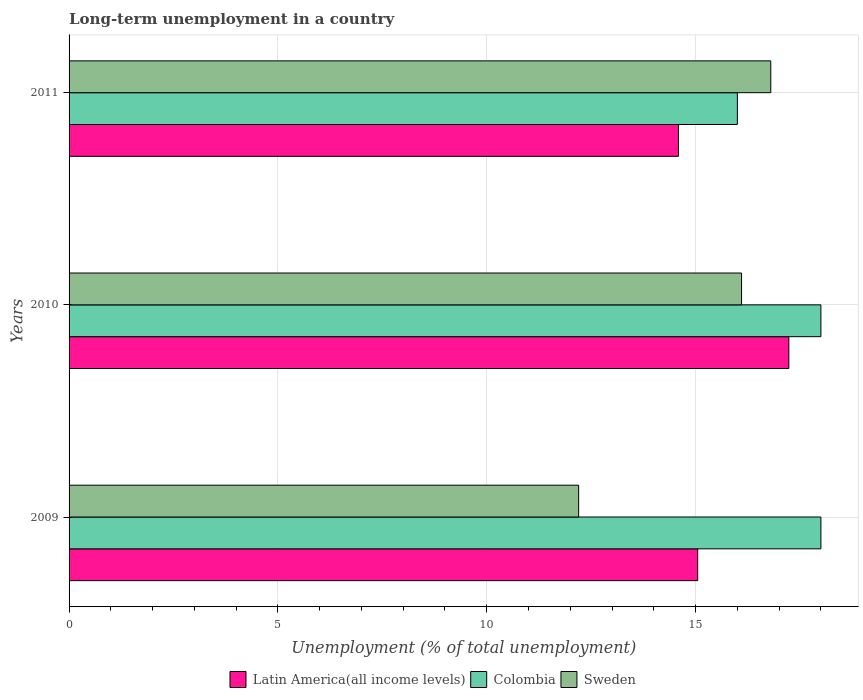Are the number of bars per tick equal to the number of legend labels?
Your answer should be compact. Yes. How many bars are there on the 1st tick from the top?
Ensure brevity in your answer.  3. How many bars are there on the 2nd tick from the bottom?
Provide a succinct answer. 3. What is the label of the 2nd group of bars from the top?
Ensure brevity in your answer.  2010. In how many cases, is the number of bars for a given year not equal to the number of legend labels?
Keep it short and to the point. 0. What is the percentage of long-term unemployed population in Sweden in 2011?
Provide a succinct answer. 16.8. Across all years, what is the maximum percentage of long-term unemployed population in Sweden?
Your answer should be compact. 16.8. Across all years, what is the minimum percentage of long-term unemployed population in Latin America(all income levels)?
Ensure brevity in your answer.  14.59. In which year was the percentage of long-term unemployed population in Colombia minimum?
Keep it short and to the point. 2011. What is the total percentage of long-term unemployed population in Colombia in the graph?
Provide a succinct answer. 52. What is the difference between the percentage of long-term unemployed population in Sweden in 2010 and the percentage of long-term unemployed population in Colombia in 2009?
Your answer should be very brief. -1.9. What is the average percentage of long-term unemployed population in Sweden per year?
Provide a short and direct response. 15.03. In the year 2009, what is the difference between the percentage of long-term unemployed population in Colombia and percentage of long-term unemployed population in Latin America(all income levels)?
Your response must be concise. 2.95. In how many years, is the percentage of long-term unemployed population in Colombia greater than 12 %?
Offer a very short reply. 3. What is the ratio of the percentage of long-term unemployed population in Latin America(all income levels) in 2010 to that in 2011?
Provide a succinct answer. 1.18. Is the percentage of long-term unemployed population in Colombia in 2010 less than that in 2011?
Offer a very short reply. No. Is the difference between the percentage of long-term unemployed population in Colombia in 2010 and 2011 greater than the difference between the percentage of long-term unemployed population in Latin America(all income levels) in 2010 and 2011?
Your answer should be very brief. No. What is the difference between the highest and the second highest percentage of long-term unemployed population in Colombia?
Your answer should be very brief. 0. What is the difference between the highest and the lowest percentage of long-term unemployed population in Sweden?
Your answer should be compact. 4.6. In how many years, is the percentage of long-term unemployed population in Colombia greater than the average percentage of long-term unemployed population in Colombia taken over all years?
Make the answer very short. 2. What does the 3rd bar from the top in 2010 represents?
Provide a succinct answer. Latin America(all income levels). Is it the case that in every year, the sum of the percentage of long-term unemployed population in Colombia and percentage of long-term unemployed population in Sweden is greater than the percentage of long-term unemployed population in Latin America(all income levels)?
Make the answer very short. Yes. How many bars are there?
Provide a succinct answer. 9. Are all the bars in the graph horizontal?
Your answer should be compact. Yes. How many years are there in the graph?
Offer a terse response. 3. What is the difference between two consecutive major ticks on the X-axis?
Give a very brief answer. 5. Are the values on the major ticks of X-axis written in scientific E-notation?
Ensure brevity in your answer.  No. Does the graph contain any zero values?
Keep it short and to the point. No. Does the graph contain grids?
Give a very brief answer. Yes. Where does the legend appear in the graph?
Give a very brief answer. Bottom center. What is the title of the graph?
Your answer should be compact. Long-term unemployment in a country. What is the label or title of the X-axis?
Ensure brevity in your answer.  Unemployment (% of total unemployment). What is the Unemployment (% of total unemployment) in Latin America(all income levels) in 2009?
Offer a terse response. 15.05. What is the Unemployment (% of total unemployment) in Sweden in 2009?
Your response must be concise. 12.2. What is the Unemployment (% of total unemployment) of Latin America(all income levels) in 2010?
Make the answer very short. 17.23. What is the Unemployment (% of total unemployment) in Sweden in 2010?
Your response must be concise. 16.1. What is the Unemployment (% of total unemployment) in Latin America(all income levels) in 2011?
Your response must be concise. 14.59. What is the Unemployment (% of total unemployment) of Sweden in 2011?
Your answer should be very brief. 16.8. Across all years, what is the maximum Unemployment (% of total unemployment) in Latin America(all income levels)?
Your answer should be compact. 17.23. Across all years, what is the maximum Unemployment (% of total unemployment) of Sweden?
Your answer should be compact. 16.8. Across all years, what is the minimum Unemployment (% of total unemployment) of Latin America(all income levels)?
Offer a terse response. 14.59. Across all years, what is the minimum Unemployment (% of total unemployment) of Colombia?
Give a very brief answer. 16. Across all years, what is the minimum Unemployment (% of total unemployment) in Sweden?
Ensure brevity in your answer.  12.2. What is the total Unemployment (% of total unemployment) of Latin America(all income levels) in the graph?
Give a very brief answer. 46.87. What is the total Unemployment (% of total unemployment) in Colombia in the graph?
Provide a short and direct response. 52. What is the total Unemployment (% of total unemployment) in Sweden in the graph?
Provide a succinct answer. 45.1. What is the difference between the Unemployment (% of total unemployment) in Latin America(all income levels) in 2009 and that in 2010?
Ensure brevity in your answer.  -2.18. What is the difference between the Unemployment (% of total unemployment) of Colombia in 2009 and that in 2010?
Offer a terse response. 0. What is the difference between the Unemployment (% of total unemployment) in Latin America(all income levels) in 2009 and that in 2011?
Your response must be concise. 0.46. What is the difference between the Unemployment (% of total unemployment) of Colombia in 2009 and that in 2011?
Your response must be concise. 2. What is the difference between the Unemployment (% of total unemployment) in Latin America(all income levels) in 2010 and that in 2011?
Make the answer very short. 2.64. What is the difference between the Unemployment (% of total unemployment) in Sweden in 2010 and that in 2011?
Provide a short and direct response. -0.7. What is the difference between the Unemployment (% of total unemployment) of Latin America(all income levels) in 2009 and the Unemployment (% of total unemployment) of Colombia in 2010?
Your answer should be very brief. -2.95. What is the difference between the Unemployment (% of total unemployment) of Latin America(all income levels) in 2009 and the Unemployment (% of total unemployment) of Sweden in 2010?
Your answer should be very brief. -1.05. What is the difference between the Unemployment (% of total unemployment) in Latin America(all income levels) in 2009 and the Unemployment (% of total unemployment) in Colombia in 2011?
Provide a short and direct response. -0.95. What is the difference between the Unemployment (% of total unemployment) in Latin America(all income levels) in 2009 and the Unemployment (% of total unemployment) in Sweden in 2011?
Offer a very short reply. -1.75. What is the difference between the Unemployment (% of total unemployment) in Colombia in 2009 and the Unemployment (% of total unemployment) in Sweden in 2011?
Offer a very short reply. 1.2. What is the difference between the Unemployment (% of total unemployment) in Latin America(all income levels) in 2010 and the Unemployment (% of total unemployment) in Colombia in 2011?
Your response must be concise. 1.23. What is the difference between the Unemployment (% of total unemployment) of Latin America(all income levels) in 2010 and the Unemployment (% of total unemployment) of Sweden in 2011?
Offer a terse response. 0.43. What is the difference between the Unemployment (% of total unemployment) of Colombia in 2010 and the Unemployment (% of total unemployment) of Sweden in 2011?
Offer a terse response. 1.2. What is the average Unemployment (% of total unemployment) in Latin America(all income levels) per year?
Ensure brevity in your answer.  15.62. What is the average Unemployment (% of total unemployment) in Colombia per year?
Provide a succinct answer. 17.33. What is the average Unemployment (% of total unemployment) in Sweden per year?
Your answer should be very brief. 15.03. In the year 2009, what is the difference between the Unemployment (% of total unemployment) in Latin America(all income levels) and Unemployment (% of total unemployment) in Colombia?
Your answer should be compact. -2.95. In the year 2009, what is the difference between the Unemployment (% of total unemployment) of Latin America(all income levels) and Unemployment (% of total unemployment) of Sweden?
Offer a terse response. 2.85. In the year 2010, what is the difference between the Unemployment (% of total unemployment) in Latin America(all income levels) and Unemployment (% of total unemployment) in Colombia?
Offer a very short reply. -0.77. In the year 2010, what is the difference between the Unemployment (% of total unemployment) of Latin America(all income levels) and Unemployment (% of total unemployment) of Sweden?
Ensure brevity in your answer.  1.13. In the year 2011, what is the difference between the Unemployment (% of total unemployment) in Latin America(all income levels) and Unemployment (% of total unemployment) in Colombia?
Provide a succinct answer. -1.41. In the year 2011, what is the difference between the Unemployment (% of total unemployment) in Latin America(all income levels) and Unemployment (% of total unemployment) in Sweden?
Keep it short and to the point. -2.21. What is the ratio of the Unemployment (% of total unemployment) in Latin America(all income levels) in 2009 to that in 2010?
Keep it short and to the point. 0.87. What is the ratio of the Unemployment (% of total unemployment) in Colombia in 2009 to that in 2010?
Keep it short and to the point. 1. What is the ratio of the Unemployment (% of total unemployment) of Sweden in 2009 to that in 2010?
Provide a succinct answer. 0.76. What is the ratio of the Unemployment (% of total unemployment) of Latin America(all income levels) in 2009 to that in 2011?
Offer a terse response. 1.03. What is the ratio of the Unemployment (% of total unemployment) in Colombia in 2009 to that in 2011?
Your response must be concise. 1.12. What is the ratio of the Unemployment (% of total unemployment) of Sweden in 2009 to that in 2011?
Give a very brief answer. 0.73. What is the ratio of the Unemployment (% of total unemployment) of Latin America(all income levels) in 2010 to that in 2011?
Your answer should be compact. 1.18. What is the ratio of the Unemployment (% of total unemployment) in Sweden in 2010 to that in 2011?
Make the answer very short. 0.96. What is the difference between the highest and the second highest Unemployment (% of total unemployment) in Latin America(all income levels)?
Keep it short and to the point. 2.18. What is the difference between the highest and the lowest Unemployment (% of total unemployment) of Latin America(all income levels)?
Offer a very short reply. 2.64. What is the difference between the highest and the lowest Unemployment (% of total unemployment) in Colombia?
Your answer should be compact. 2. 